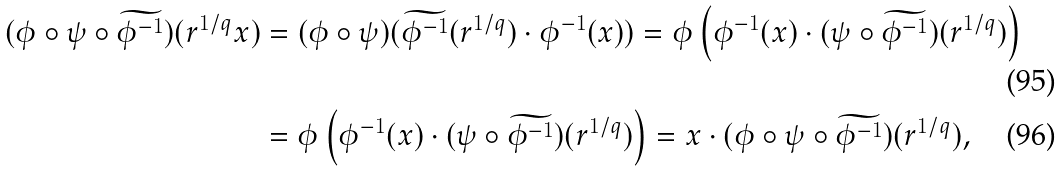<formula> <loc_0><loc_0><loc_500><loc_500>( \phi \circ \psi \circ \widetilde { \phi ^ { - 1 } } ) ( r ^ { 1 / q } x ) & = ( \phi \circ \psi ) ( \widetilde { \phi ^ { - 1 } } ( r ^ { 1 / q } ) \cdot \phi ^ { - 1 } ( x ) ) = \phi \left ( \phi ^ { - 1 } ( x ) \cdot ( \psi \circ \widetilde { \phi ^ { - 1 } } ) ( r ^ { 1 / q } ) \right ) \\ & = \phi \left ( \phi ^ { - 1 } ( x ) \cdot ( \psi \circ \widetilde { \phi ^ { - 1 } } ) ( r ^ { 1 / q } ) \right ) = x \cdot ( \phi \circ \psi \circ \widetilde { \phi ^ { - 1 } } ) ( r ^ { 1 / q } ) ,</formula> 